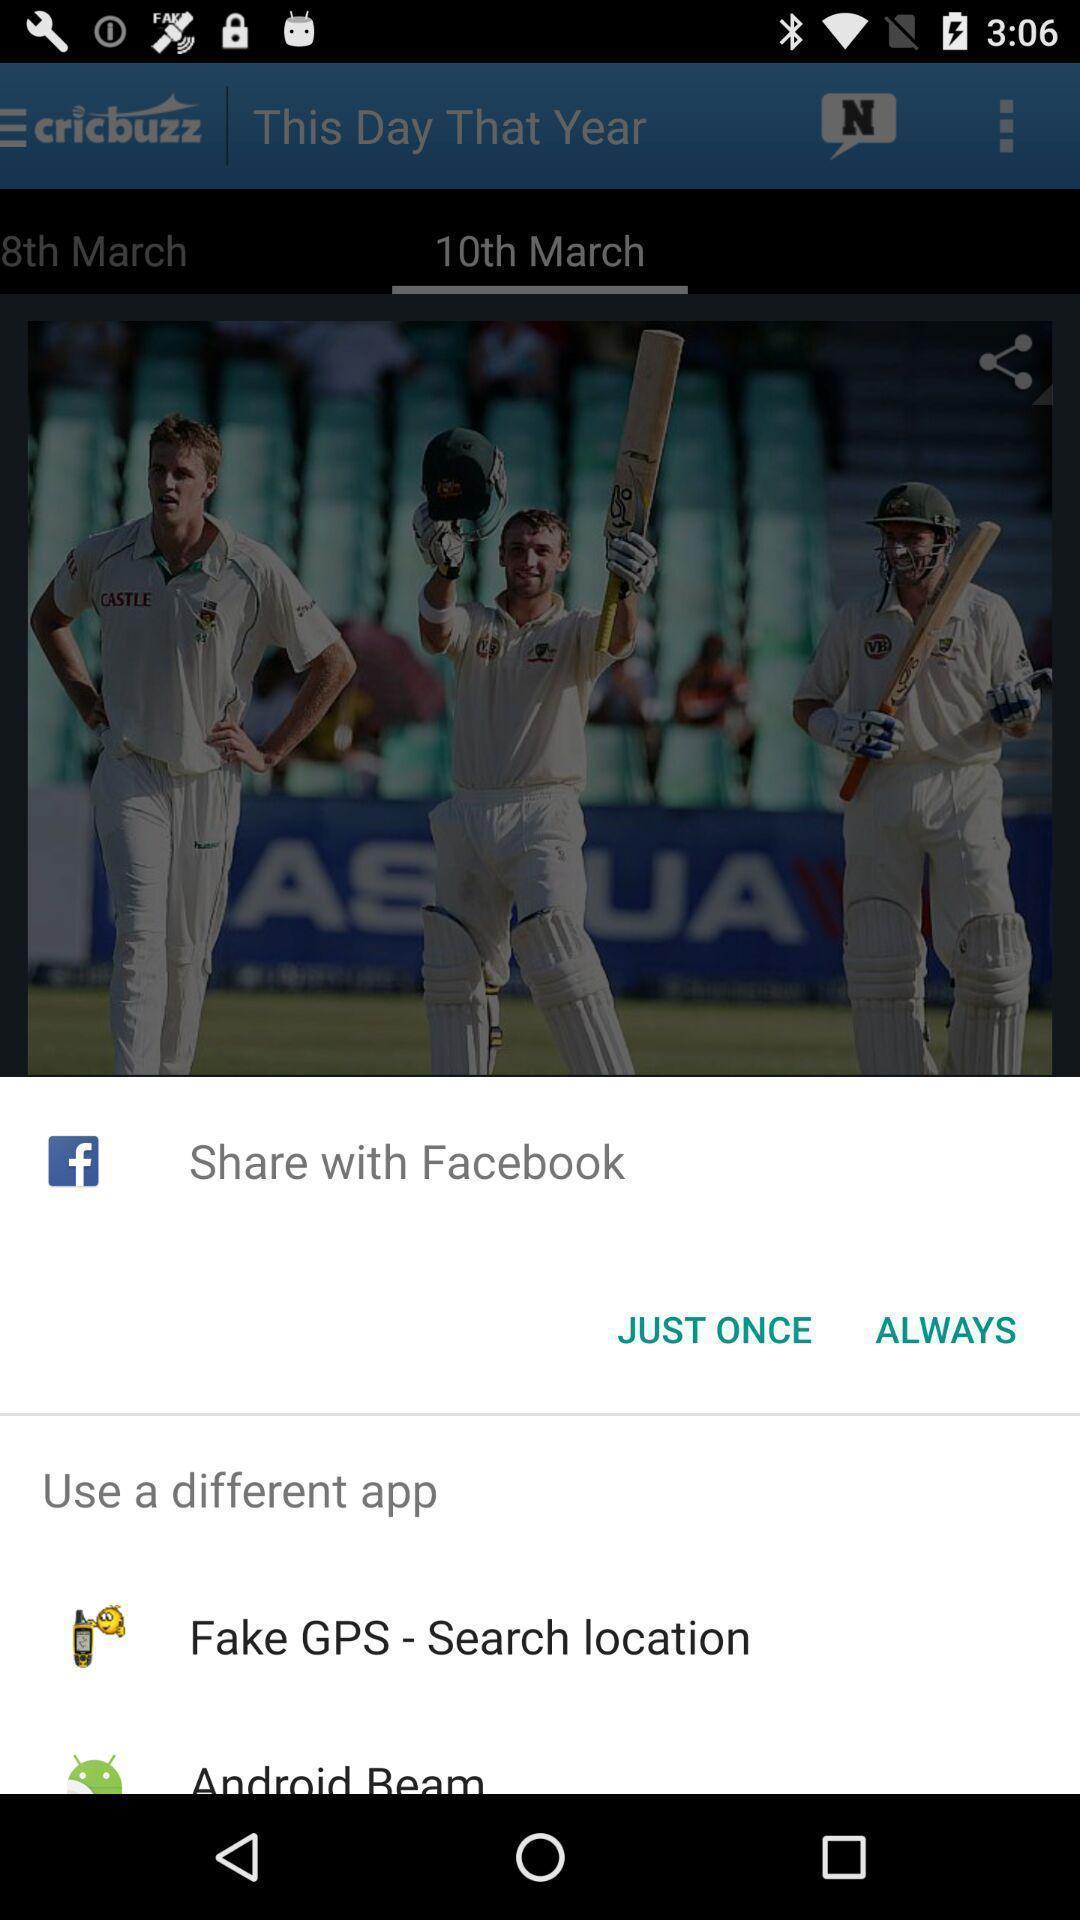Provide a detailed account of this screenshot. Pop-up shows share option with social application. 